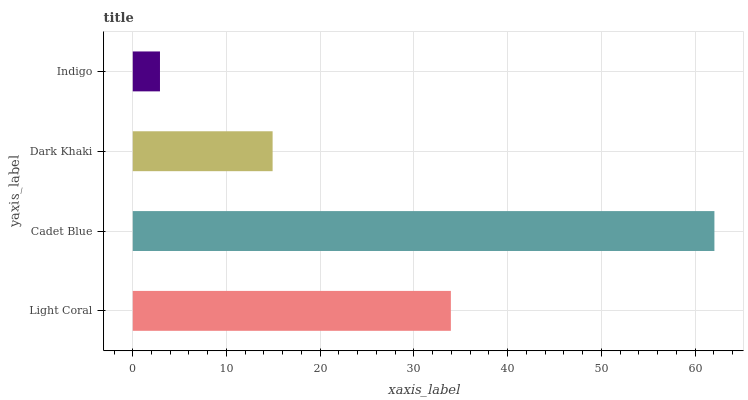Is Indigo the minimum?
Answer yes or no. Yes. Is Cadet Blue the maximum?
Answer yes or no. Yes. Is Dark Khaki the minimum?
Answer yes or no. No. Is Dark Khaki the maximum?
Answer yes or no. No. Is Cadet Blue greater than Dark Khaki?
Answer yes or no. Yes. Is Dark Khaki less than Cadet Blue?
Answer yes or no. Yes. Is Dark Khaki greater than Cadet Blue?
Answer yes or no. No. Is Cadet Blue less than Dark Khaki?
Answer yes or no. No. Is Light Coral the high median?
Answer yes or no. Yes. Is Dark Khaki the low median?
Answer yes or no. Yes. Is Indigo the high median?
Answer yes or no. No. Is Light Coral the low median?
Answer yes or no. No. 